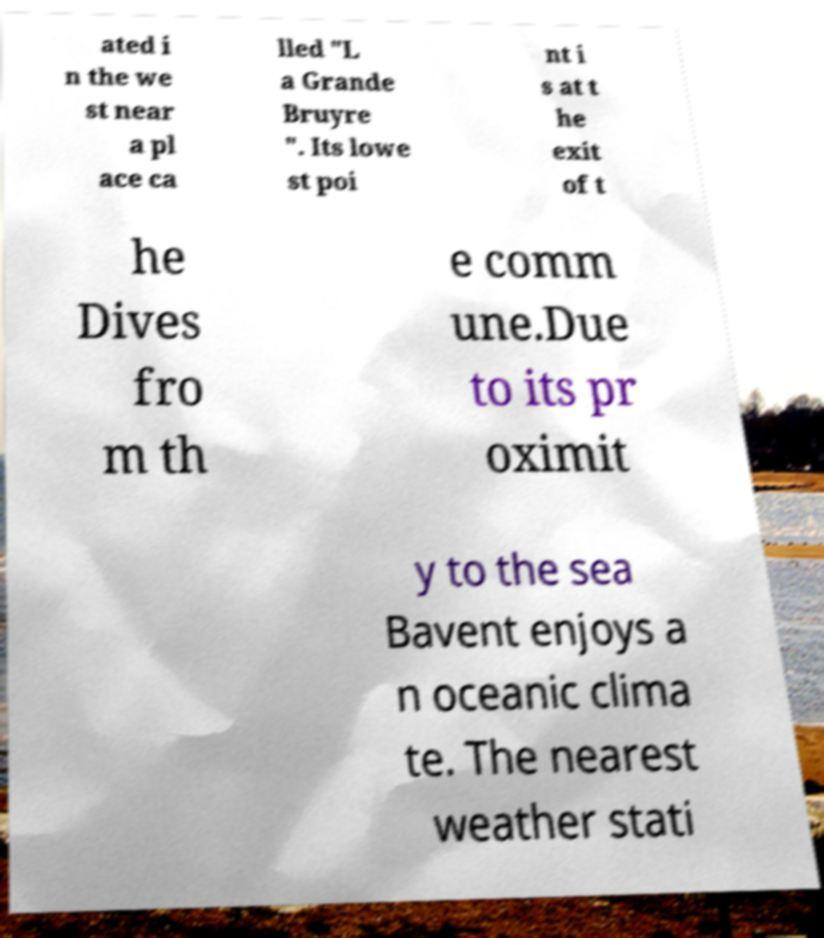Please read and relay the text visible in this image. What does it say? ated i n the we st near a pl ace ca lled "L a Grande Bruyre ". Its lowe st poi nt i s at t he exit of t he Dives fro m th e comm une.Due to its pr oximit y to the sea Bavent enjoys a n oceanic clima te. The nearest weather stati 